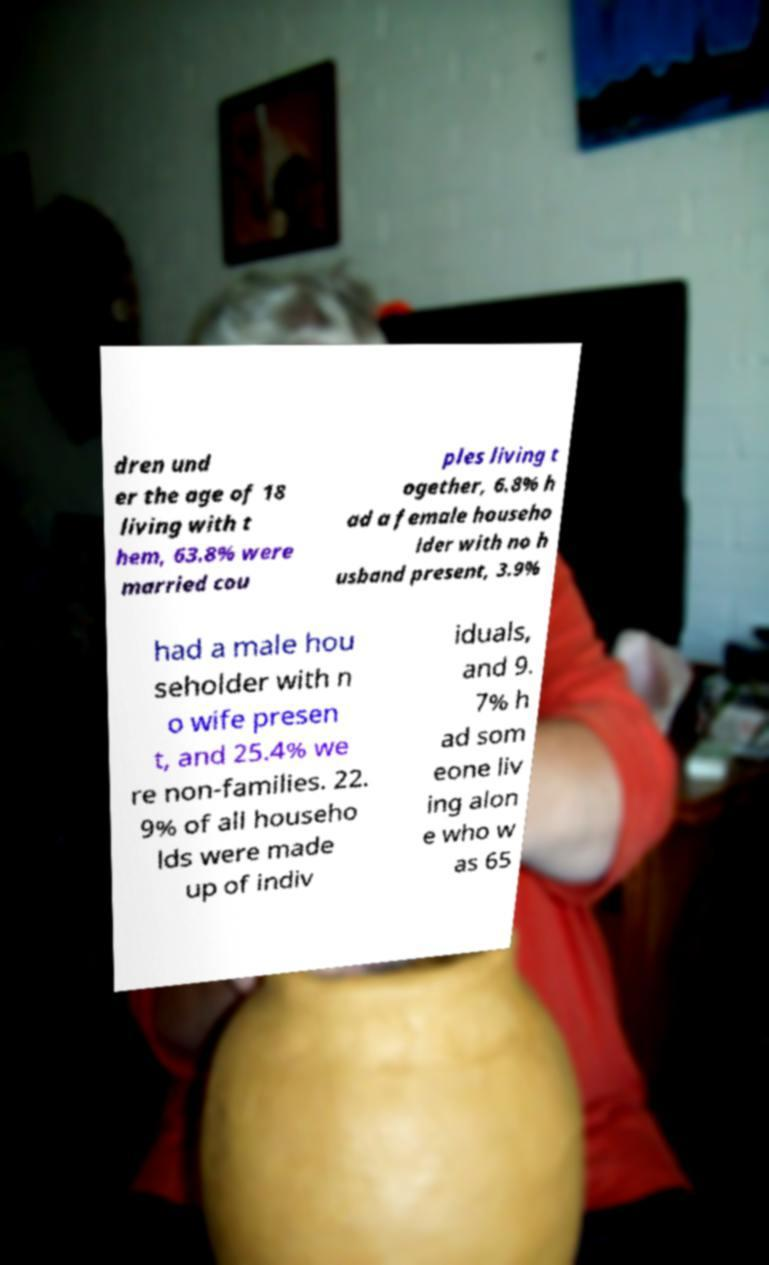The paper contains statistical information. Could this image relate to a study or research? It's plausible that the paper held in the foreground is part of a study or research document, given the statistical nature of the text discussing household demographics. However, without additional context or visibility of the entire document, it's not possible to ascertain the exact nature or origin of the paper. 